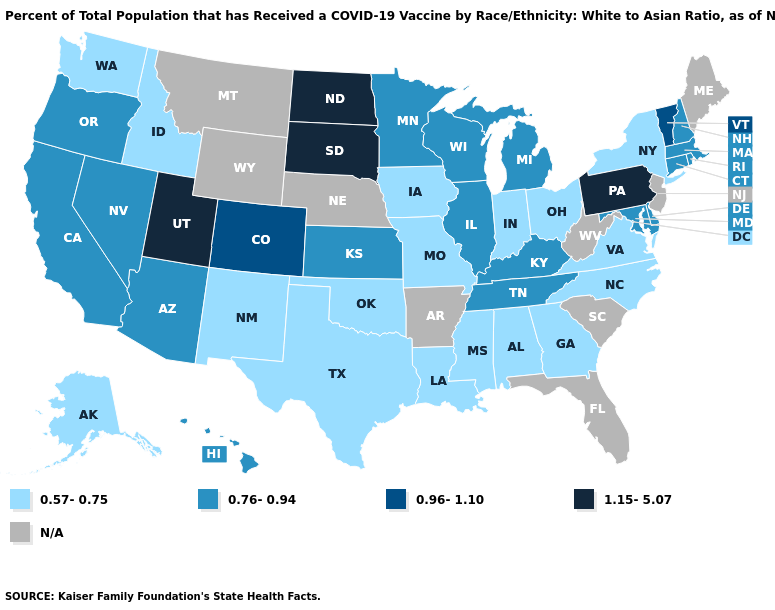Does Rhode Island have the lowest value in the Northeast?
Answer briefly. No. What is the value of Idaho?
Give a very brief answer. 0.57-0.75. Which states have the lowest value in the South?
Keep it brief. Alabama, Georgia, Louisiana, Mississippi, North Carolina, Oklahoma, Texas, Virginia. What is the value of Kansas?
Quick response, please. 0.76-0.94. Among the states that border Texas , which have the lowest value?
Keep it brief. Louisiana, New Mexico, Oklahoma. What is the highest value in states that border Pennsylvania?
Write a very short answer. 0.76-0.94. How many symbols are there in the legend?
Quick response, please. 5. Does the map have missing data?
Answer briefly. Yes. Does the first symbol in the legend represent the smallest category?
Concise answer only. Yes. Which states hav the highest value in the Northeast?
Short answer required. Pennsylvania. What is the value of Kentucky?
Write a very short answer. 0.76-0.94. Does Georgia have the lowest value in the USA?
Concise answer only. Yes. What is the value of Tennessee?
Short answer required. 0.76-0.94. How many symbols are there in the legend?
Quick response, please. 5. Name the states that have a value in the range 1.15-5.07?
Quick response, please. North Dakota, Pennsylvania, South Dakota, Utah. 